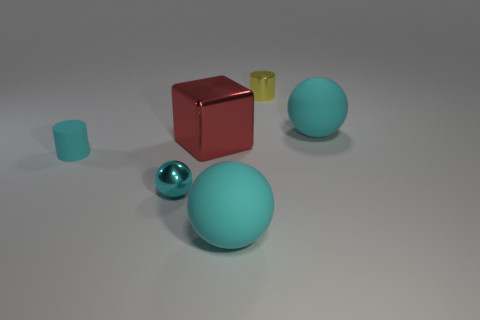How many other objects are there of the same color as the metallic cylinder?
Offer a terse response. 0. Does the metallic cylinder have the same size as the red cube?
Give a very brief answer. No. What number of things are big cyan rubber objects or large cyan matte objects in front of the small cyan metallic sphere?
Your answer should be very brief. 2. Are there fewer big metal cubes that are in front of the large cube than large matte things that are on the left side of the tiny yellow cylinder?
Your response must be concise. Yes. What number of other objects are the same material as the yellow thing?
Give a very brief answer. 2. Does the large object to the right of the yellow cylinder have the same color as the large metal cube?
Offer a terse response. No. Are there any large matte things that are in front of the matte ball behind the small sphere?
Your answer should be compact. Yes. The thing that is on the left side of the red metal cube and in front of the matte cylinder is made of what material?
Provide a short and direct response. Metal. What shape is the red object that is made of the same material as the tiny yellow cylinder?
Your response must be concise. Cube. Are there any other things that are the same shape as the large shiny thing?
Offer a very short reply. No. 